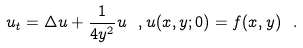<formula> <loc_0><loc_0><loc_500><loc_500>u _ { t } = \Delta u + \frac { 1 } { 4 y ^ { 2 } } u \ , u ( x , y ; 0 ) = f ( x , y ) \ .</formula> 